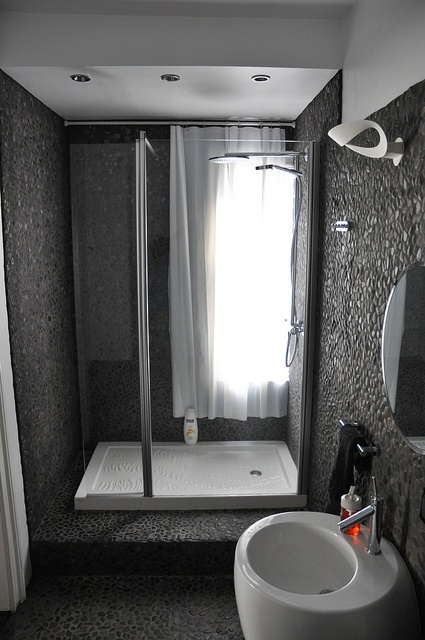Describe the objects in this image and their specific colors. I can see a sink in black, gray, and lightgray tones in this image. 